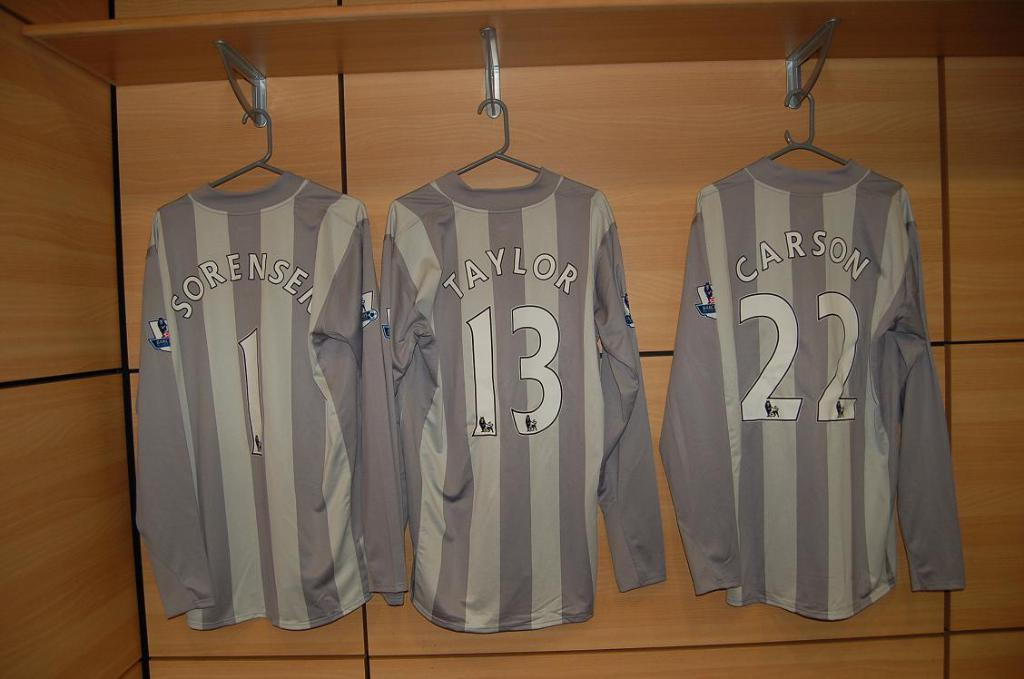<image>
Create a compact narrative representing the image presented. A jersey in the center of two other jerseys has the number 13 on it. 